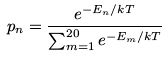Convert formula to latex. <formula><loc_0><loc_0><loc_500><loc_500>p _ { n } = \frac { e ^ { - E _ { n } / k T } } { \sum _ { m = 1 } ^ { 2 0 } e ^ { - E _ { m } / k T } }</formula> 